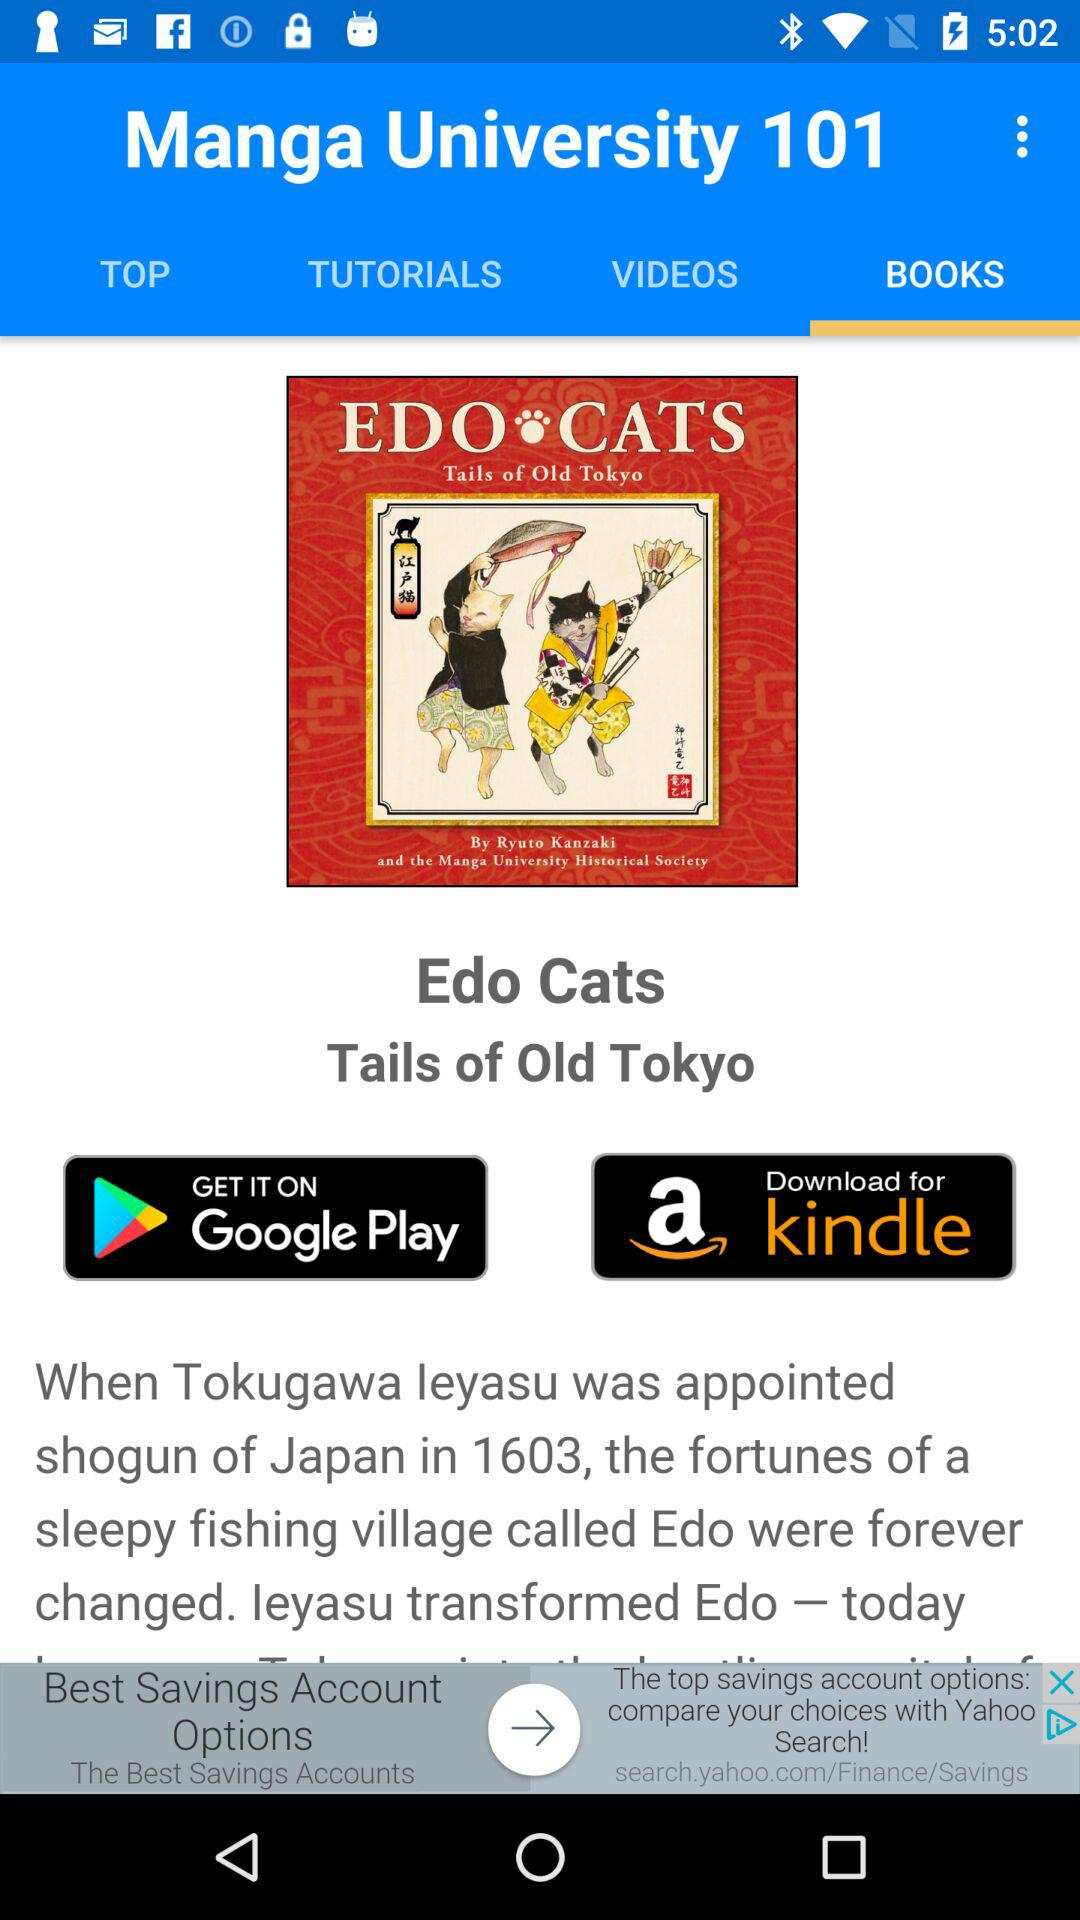What is the app name? The app name is "Manga University 101". 